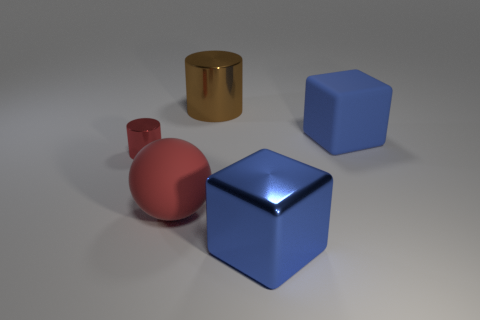Add 4 small cyan rubber balls. How many objects exist? 9 Subtract all cylinders. How many objects are left? 3 Subtract all blue blocks. Subtract all large shiny cubes. How many objects are left? 2 Add 2 large brown cylinders. How many large brown cylinders are left? 3 Add 4 large gray rubber spheres. How many large gray rubber spheres exist? 4 Subtract 0 green blocks. How many objects are left? 5 